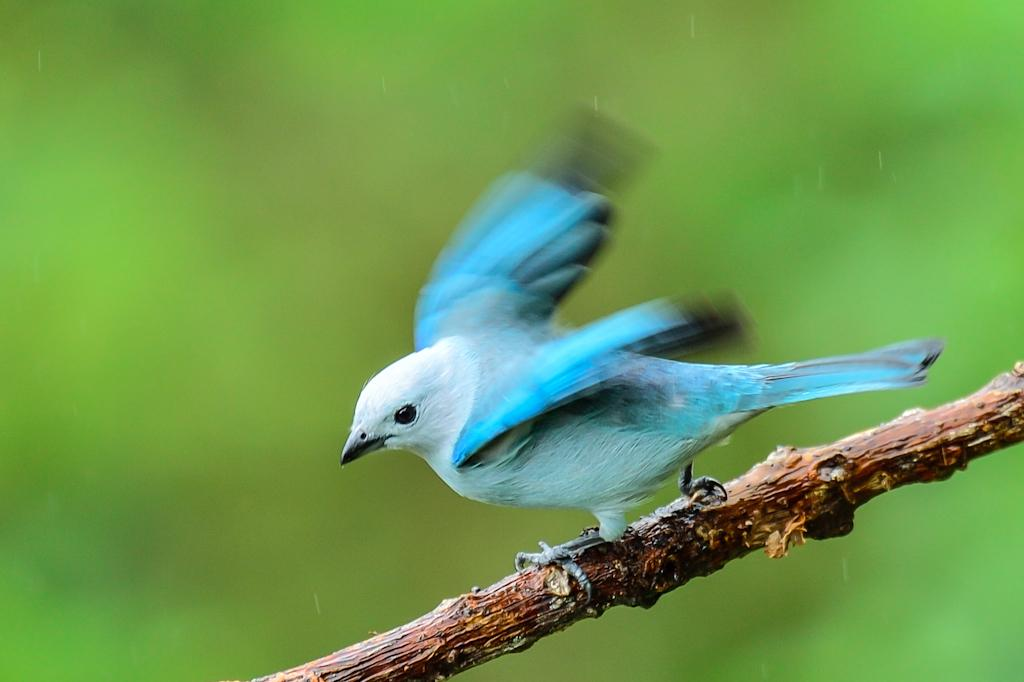What is the main subject of the image? There is a bird in the image. Where is the bird located in the image? The bird is in the center of the image. What is the bird standing on? The bird is on a stem. How many kittens are playing with the sink in the image? There are no kittens or sinks present in the image; it features a bird on a stem. 